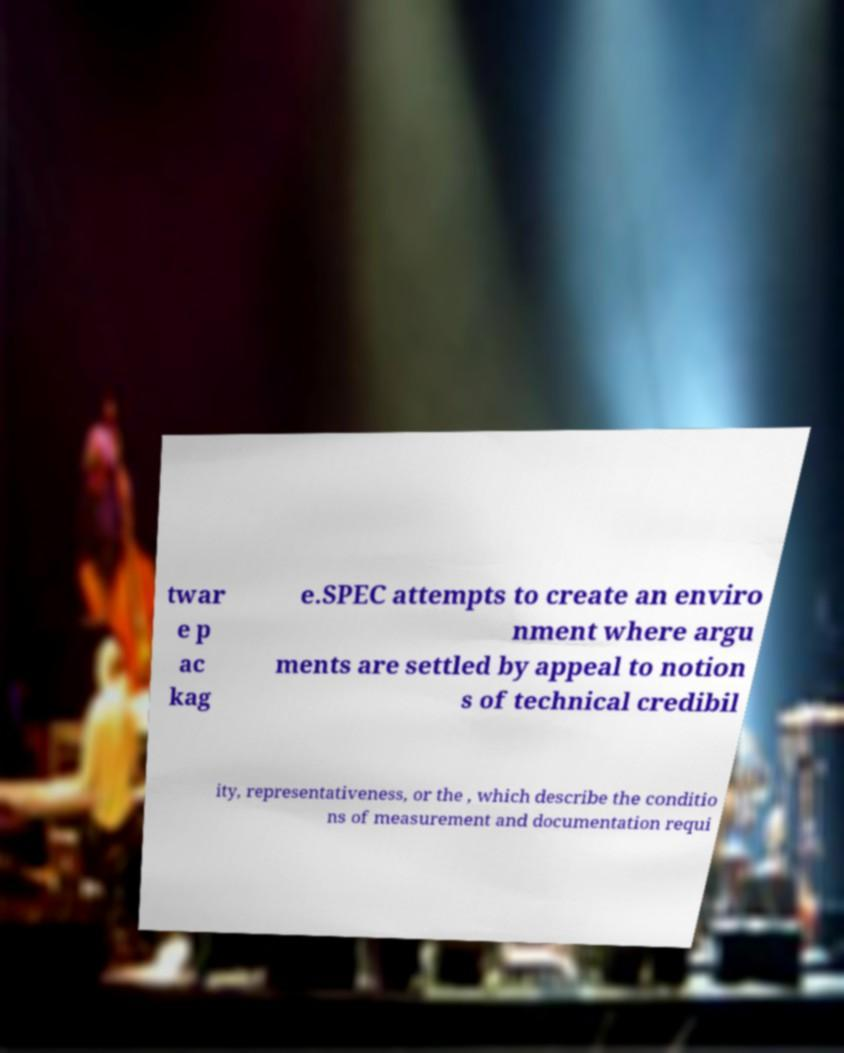For documentation purposes, I need the text within this image transcribed. Could you provide that? twar e p ac kag e.SPEC attempts to create an enviro nment where argu ments are settled by appeal to notion s of technical credibil ity, representativeness, or the , which describe the conditio ns of measurement and documentation requi 